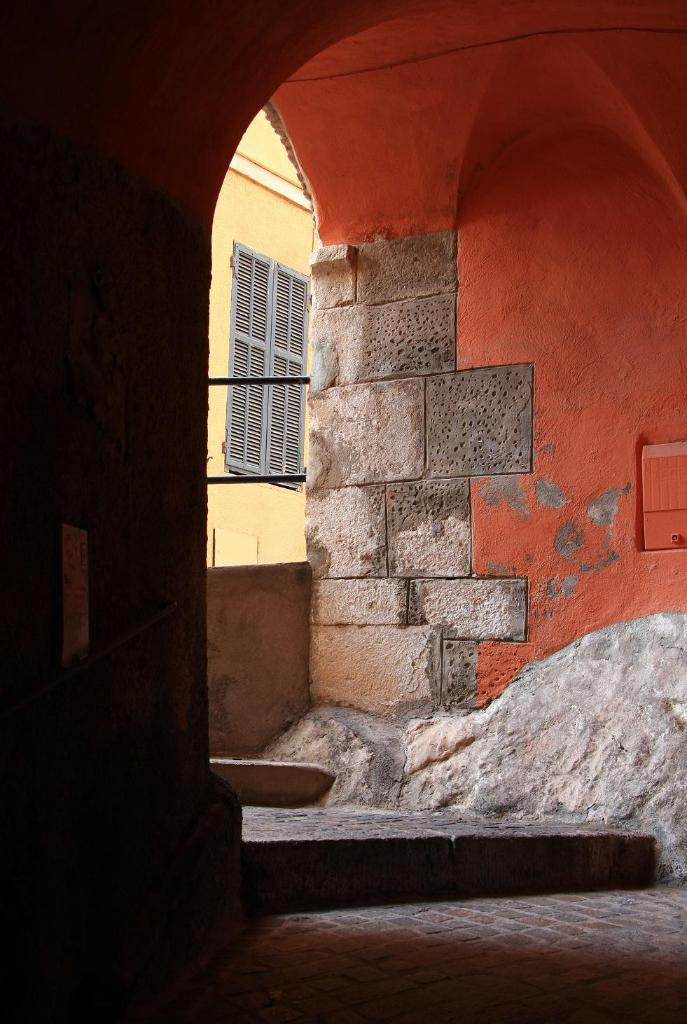What color is the wall that is in the foreground of the image? There is a red color wall in the image. What color is the wall that is in the background of the image? There is a yellow color wall in the background of the image. What can be seen in the background of the image? There is a window in the background of the image. How many worms can be seen crawling on the red wall in the image? There are no worms present in the image; it only features walls of different colors and a window in the background. 